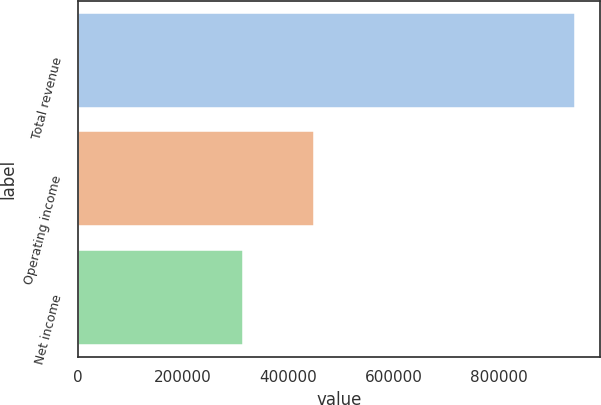Convert chart to OTSL. <chart><loc_0><loc_0><loc_500><loc_500><bar_chart><fcel>Total revenue<fcel>Operating income<fcel>Net income<nl><fcel>944478<fcel>448344<fcel>313375<nl></chart> 